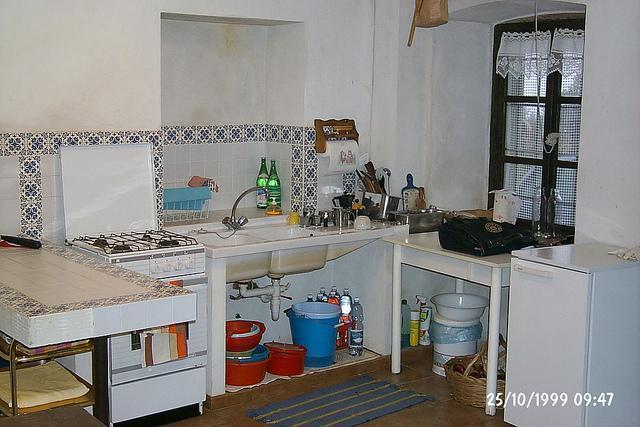What is the large circular blue object under the sink?
Choose the right answer and clarify with the format: 'Answer: answer
Rationale: rationale.'
Options: Hose, bucket, ball, mat. Answer: bucket.
Rationale: The item is made of plastic and has a handle for carrying as these items typically do, 